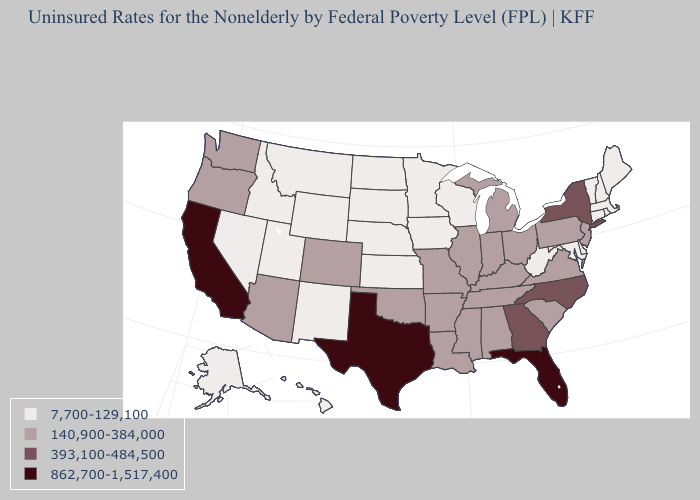Which states have the lowest value in the MidWest?
Concise answer only. Iowa, Kansas, Minnesota, Nebraska, North Dakota, South Dakota, Wisconsin. Name the states that have a value in the range 140,900-384,000?
Keep it brief. Alabama, Arizona, Arkansas, Colorado, Illinois, Indiana, Kentucky, Louisiana, Michigan, Mississippi, Missouri, New Jersey, Ohio, Oklahoma, Oregon, Pennsylvania, South Carolina, Tennessee, Virginia, Washington. Which states have the lowest value in the West?
Keep it brief. Alaska, Hawaii, Idaho, Montana, Nevada, New Mexico, Utah, Wyoming. Which states have the lowest value in the USA?
Be succinct. Alaska, Connecticut, Delaware, Hawaii, Idaho, Iowa, Kansas, Maine, Maryland, Massachusetts, Minnesota, Montana, Nebraska, Nevada, New Hampshire, New Mexico, North Dakota, Rhode Island, South Dakota, Utah, Vermont, West Virginia, Wisconsin, Wyoming. Which states hav the highest value in the Northeast?
Answer briefly. New York. Among the states that border Maine , which have the highest value?
Answer briefly. New Hampshire. How many symbols are there in the legend?
Keep it brief. 4. What is the highest value in the USA?
Answer briefly. 862,700-1,517,400. Among the states that border Arizona , does California have the highest value?
Short answer required. Yes. Is the legend a continuous bar?
Concise answer only. No. What is the lowest value in the West?
Write a very short answer. 7,700-129,100. What is the value of Virginia?
Write a very short answer. 140,900-384,000. Name the states that have a value in the range 7,700-129,100?
Give a very brief answer. Alaska, Connecticut, Delaware, Hawaii, Idaho, Iowa, Kansas, Maine, Maryland, Massachusetts, Minnesota, Montana, Nebraska, Nevada, New Hampshire, New Mexico, North Dakota, Rhode Island, South Dakota, Utah, Vermont, West Virginia, Wisconsin, Wyoming. Does Illinois have the same value as Nevada?
Short answer required. No. Does the map have missing data?
Be succinct. No. 